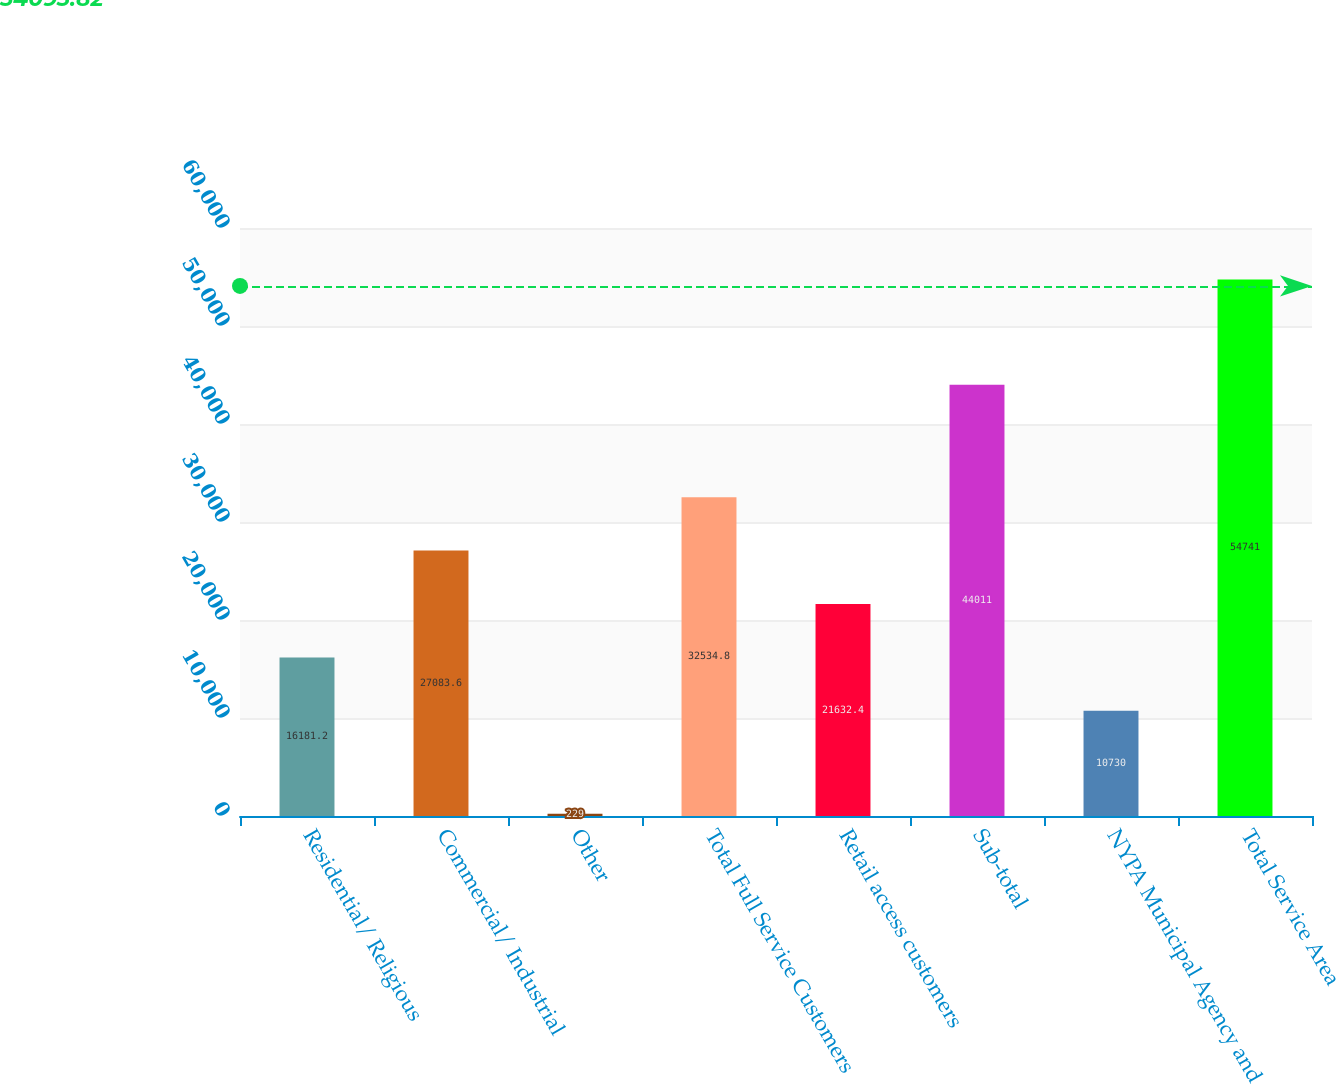<chart> <loc_0><loc_0><loc_500><loc_500><bar_chart><fcel>Residential/ Religious<fcel>Commercial/ Industrial<fcel>Other<fcel>Total Full Service Customers<fcel>Retail access customers<fcel>Sub-total<fcel>NYPA Municipal Agency and<fcel>Total Service Area<nl><fcel>16181.2<fcel>27083.6<fcel>229<fcel>32534.8<fcel>21632.4<fcel>44011<fcel>10730<fcel>54741<nl></chart> 